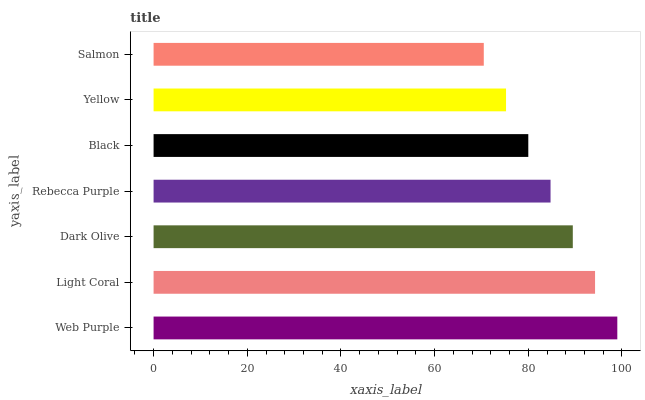Is Salmon the minimum?
Answer yes or no. Yes. Is Web Purple the maximum?
Answer yes or no. Yes. Is Light Coral the minimum?
Answer yes or no. No. Is Light Coral the maximum?
Answer yes or no. No. Is Web Purple greater than Light Coral?
Answer yes or no. Yes. Is Light Coral less than Web Purple?
Answer yes or no. Yes. Is Light Coral greater than Web Purple?
Answer yes or no. No. Is Web Purple less than Light Coral?
Answer yes or no. No. Is Rebecca Purple the high median?
Answer yes or no. Yes. Is Rebecca Purple the low median?
Answer yes or no. Yes. Is Salmon the high median?
Answer yes or no. No. Is Yellow the low median?
Answer yes or no. No. 